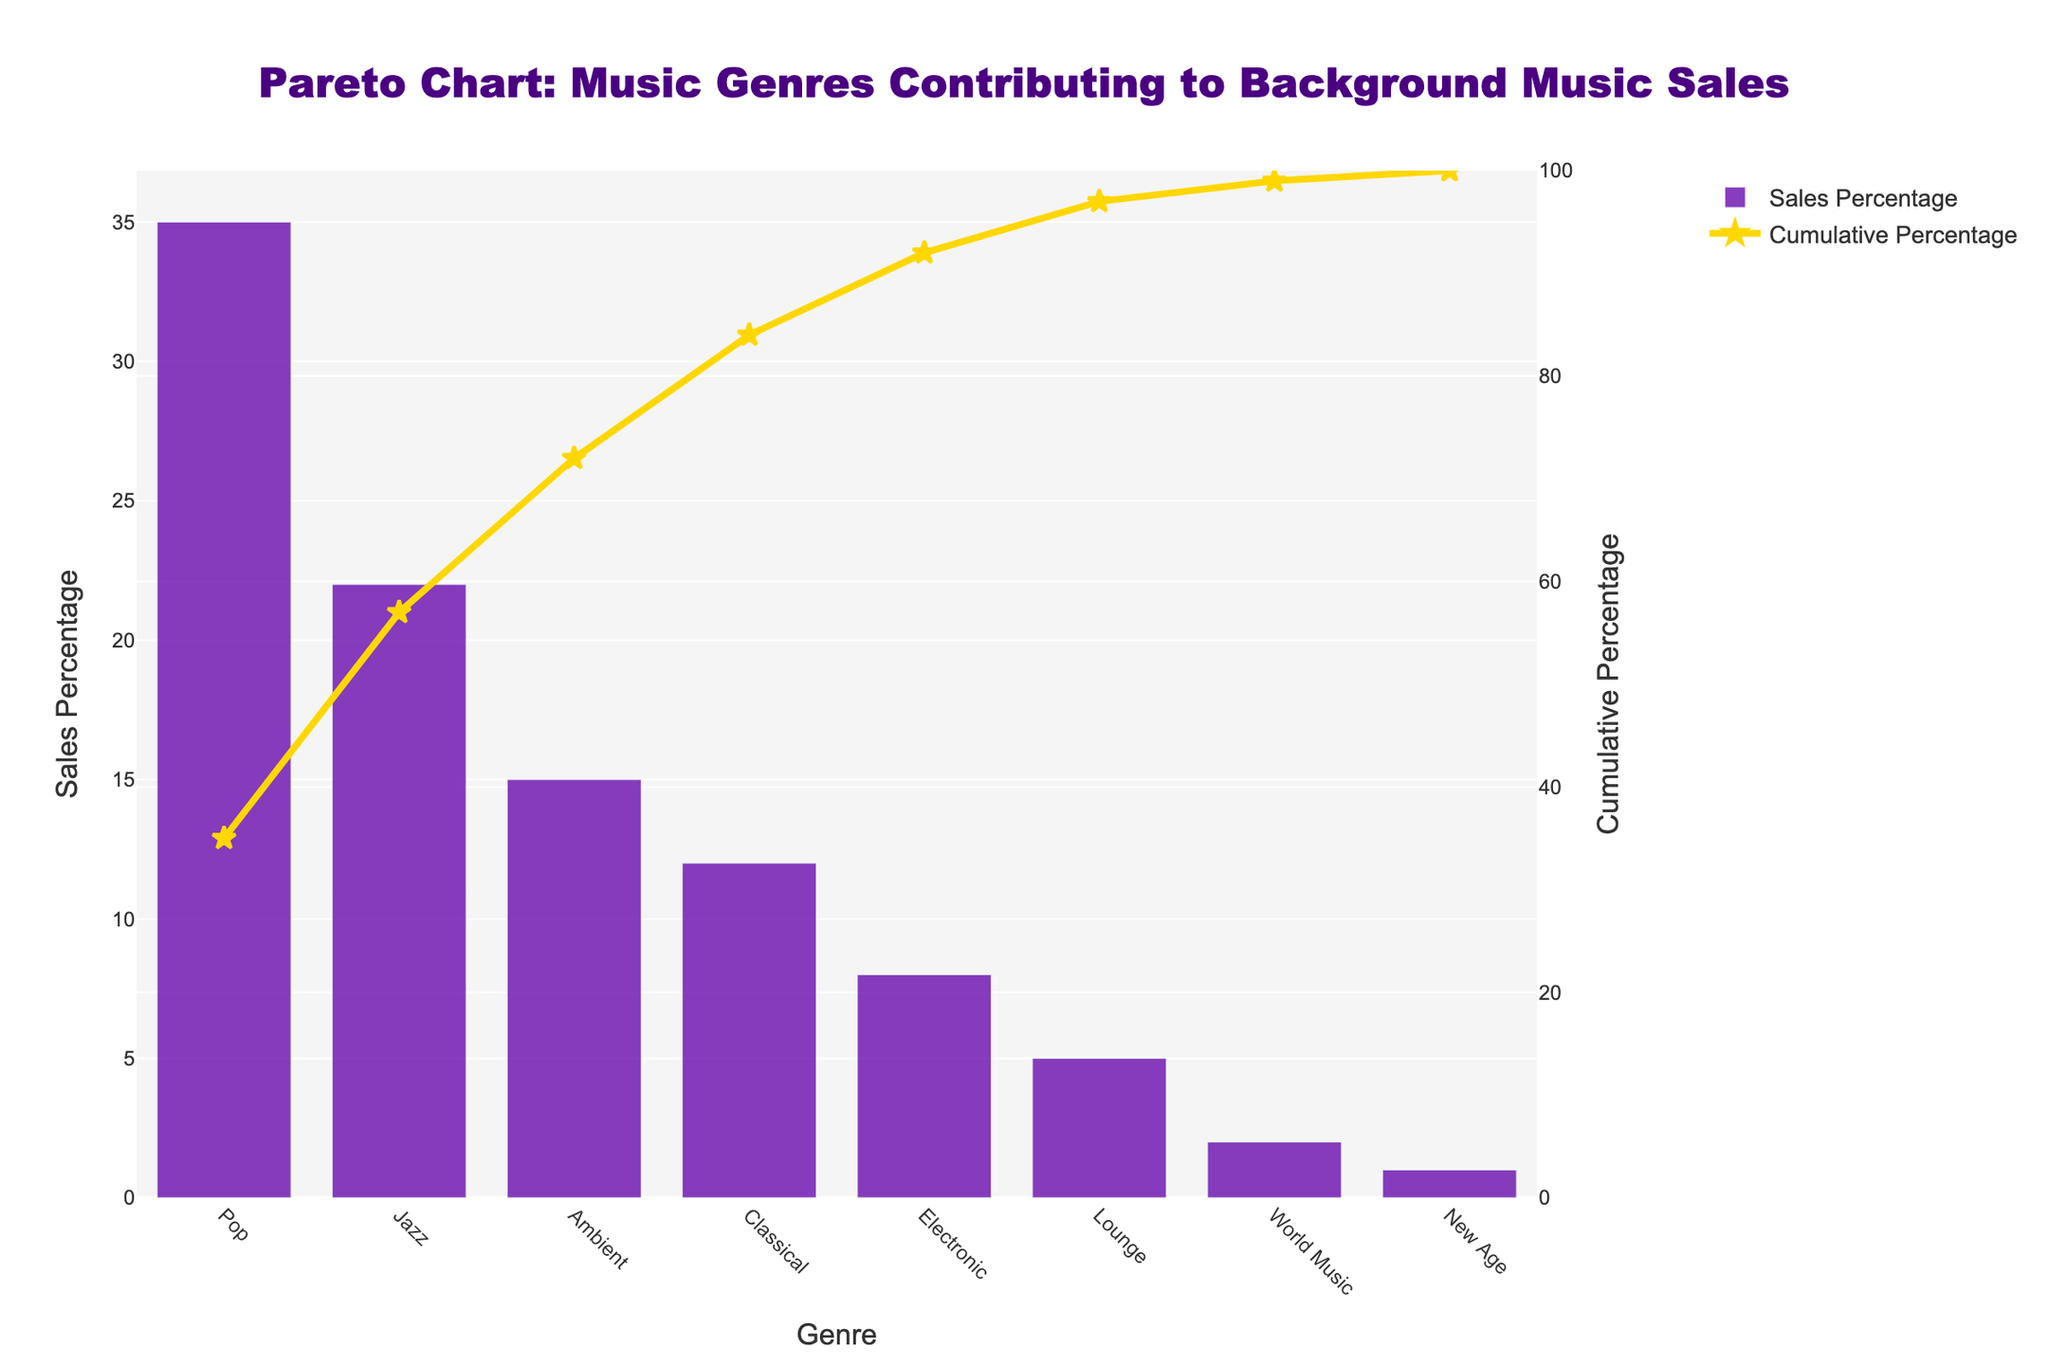What is the most popular music genre for background music sales? The bar with the highest percentage in the sales percentage graph corresponds to the Pop genre at 35%.
Answer: Pop Which music genre has the lowest sales percentage? The genre with the smallest bar in the sales percentage graph is New Age, with a sales percentage of 1%.
Answer: New Age What is the cumulative percentage after combining Pop and Jazz sales? The cumulative percentage after Pop (35%) and Jazz (22%) is the sum of these two values, which is 35% + 22% = 57%.
Answer: 57% How much higher is the sales percentage of Pop compared to Classical? The difference in sales percentage between Pop (35%) and Classical (12%) is calculated as 35% - 12%.
Answer: 23% What percentage of sales is covered by the top three genres? The top three genres are Pop (35%), Jazz (22%), and Ambient (15%). The total sales percentage covered by these genres is 35% + 22% + 15% = 72%.
Answer: 72% Is the cumulative percentage above or below 85% after including Classical music genre? The cumulative percentage after Pop, Jazz, Ambient, and Classical is 35% + 22% + 15% + 12% = 84%, which is below 85%.
Answer: Below 85% What genre reaches approximately the halfway point (50%) in cumulative percentage? By observing the cumulative percentage line, it reaches close to 50% after the Jazz genre, making Jazz the genre at the halfway point.
Answer: Jazz By what percentage do the bottom three genres (Lounge, World Music, New Age) contribute to sales? The sales percentages for Lounge (5%), World Music (2%), and New Age (1%) add up to 5% + 2% + 1% = 8%.
Answer: 8% Which genre's sales percentage makes the cumulative percentage cross 90%? Combining Pop, Jazz, Ambient, Classical, Electronic, and Lounge gives a cumulative percentage of 92%, making Lounge the genre at which this threshold is crossed.
Answer: Lounge How does the cumulative percentage curve represent the Pareto principle (80/20 rule)? The 80/20 rule states that 80% of effects come from 20% of causes. Here, observing the cumulative percentage curve, 80% cumulative is reached around the Classical genre, meaning a few top genres (Pop, Jazz, and Ambient) make up approximately 80% of sales.
Answer: Top genres make up ~80% sales 